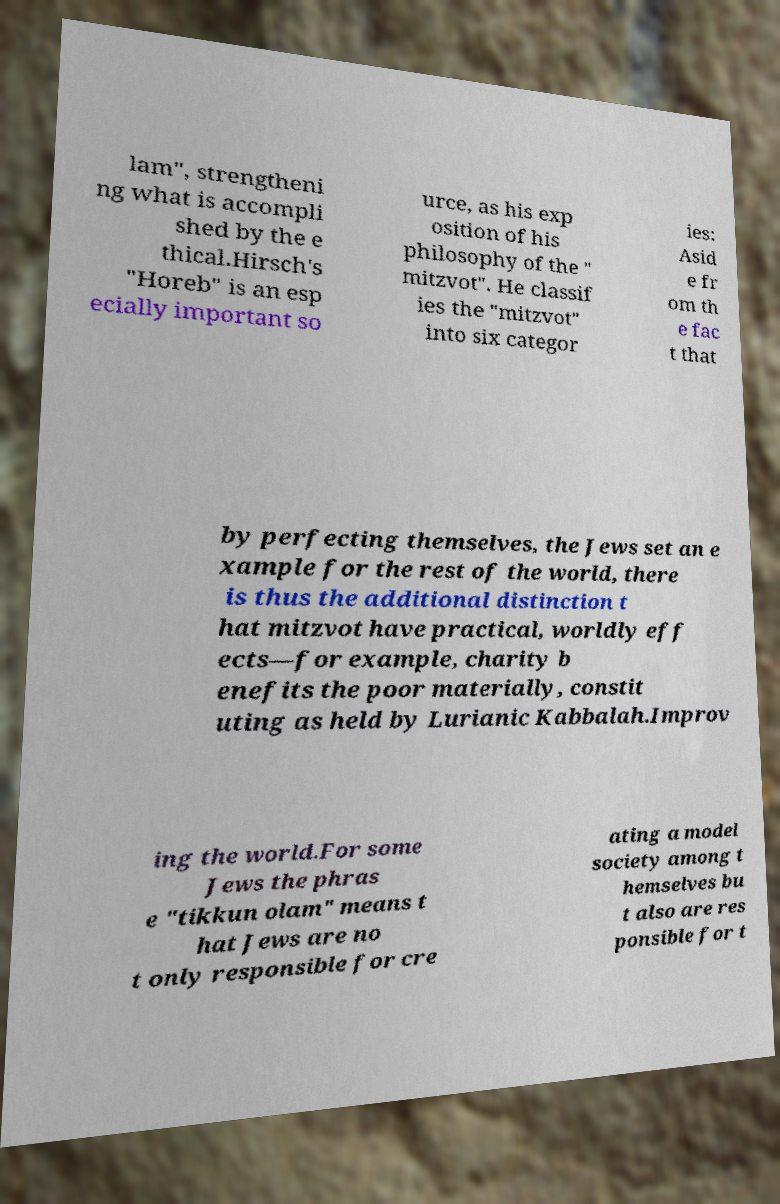For documentation purposes, I need the text within this image transcribed. Could you provide that? lam", strengtheni ng what is accompli shed by the e thical.Hirsch's "Horeb" is an esp ecially important so urce, as his exp osition of his philosophy of the " mitzvot". He classif ies the "mitzvot" into six categor ies: Asid e fr om th e fac t that by perfecting themselves, the Jews set an e xample for the rest of the world, there is thus the additional distinction t hat mitzvot have practical, worldly eff ects—for example, charity b enefits the poor materially, constit uting as held by Lurianic Kabbalah.Improv ing the world.For some Jews the phras e "tikkun olam" means t hat Jews are no t only responsible for cre ating a model society among t hemselves bu t also are res ponsible for t 